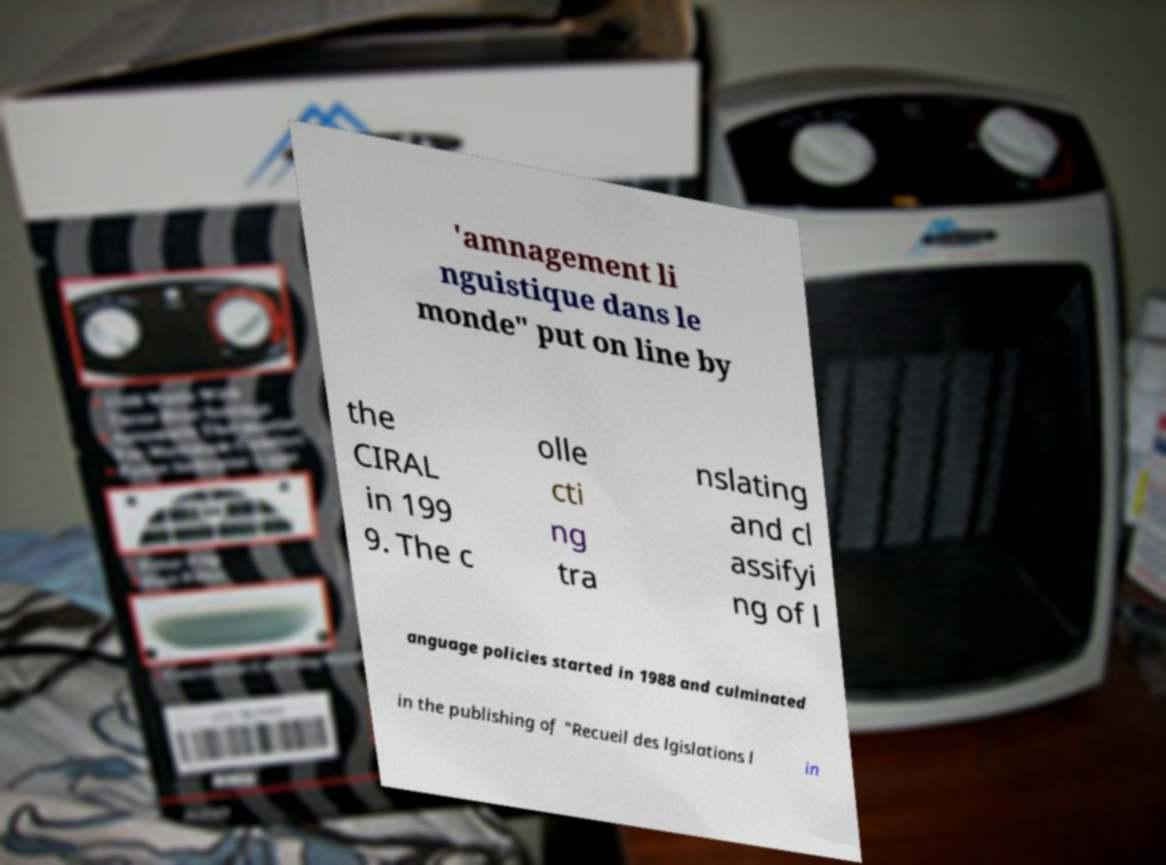Can you read and provide the text displayed in the image?This photo seems to have some interesting text. Can you extract and type it out for me? 'amnagement li nguistique dans le monde" put on line by the CIRAL in 199 9. The c olle cti ng tra nslating and cl assifyi ng of l anguage policies started in 1988 and culminated in the publishing of "Recueil des lgislations l in 